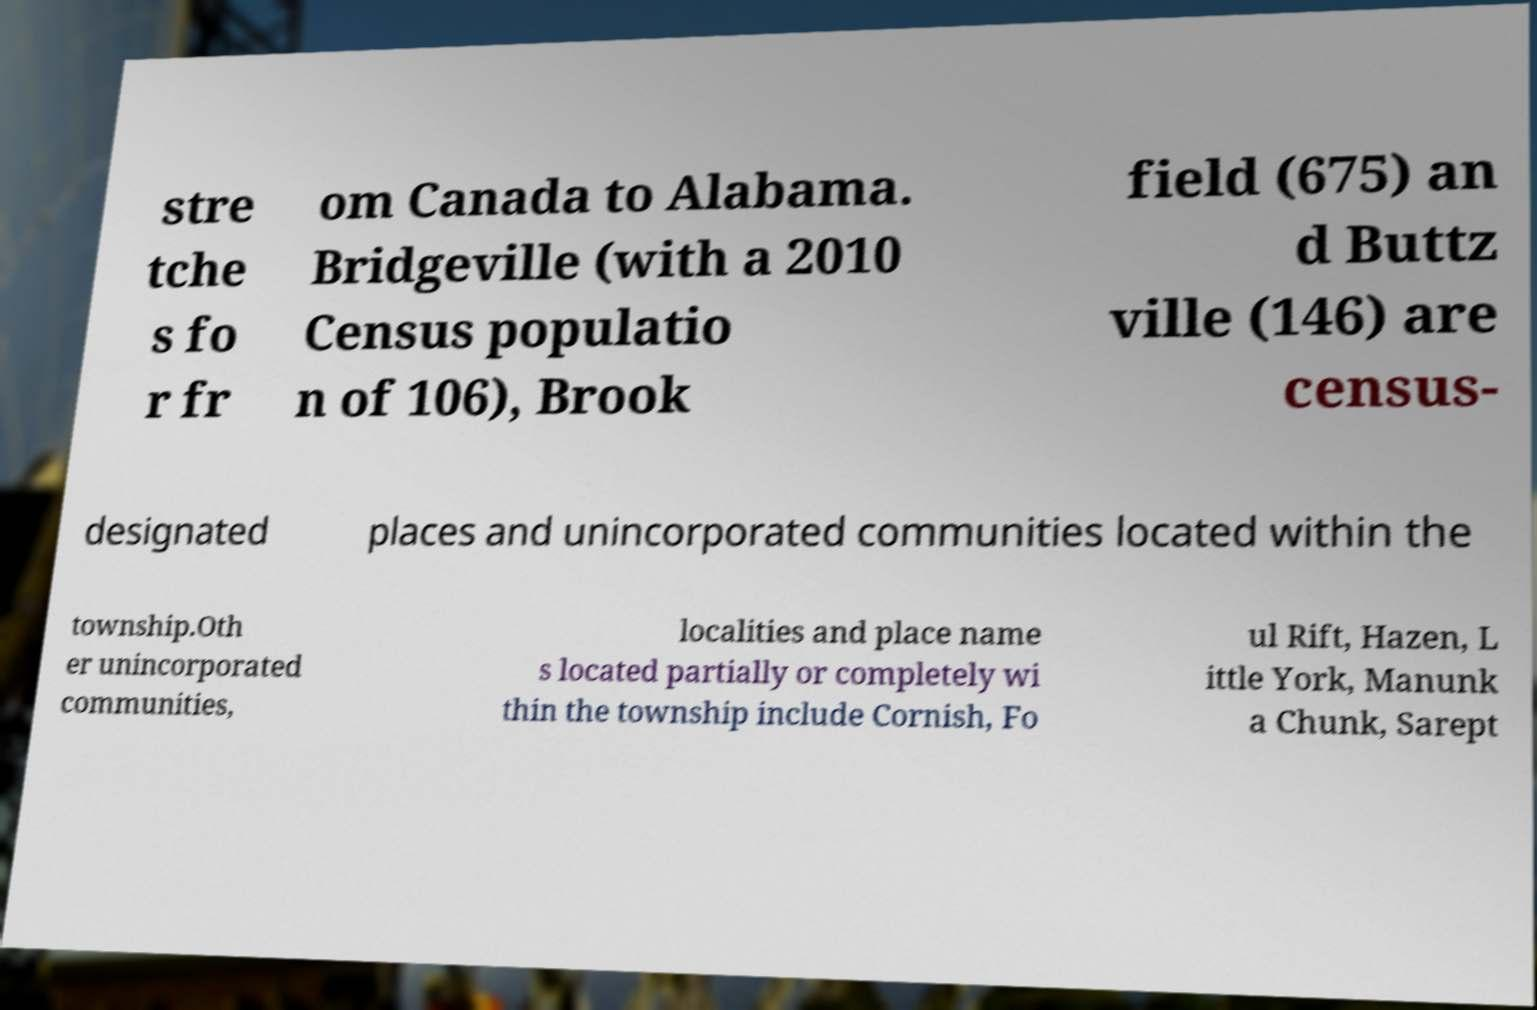I need the written content from this picture converted into text. Can you do that? stre tche s fo r fr om Canada to Alabama. Bridgeville (with a 2010 Census populatio n of 106), Brook field (675) an d Buttz ville (146) are census- designated places and unincorporated communities located within the township.Oth er unincorporated communities, localities and place name s located partially or completely wi thin the township include Cornish, Fo ul Rift, Hazen, L ittle York, Manunk a Chunk, Sarept 